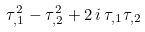<formula> <loc_0><loc_0><loc_500><loc_500>\tau _ { , 1 } ^ { 2 } - \tau _ { , 2 } ^ { 2 } + 2 \, i \, \tau _ { , 1 } \tau _ { , 2 }</formula> 